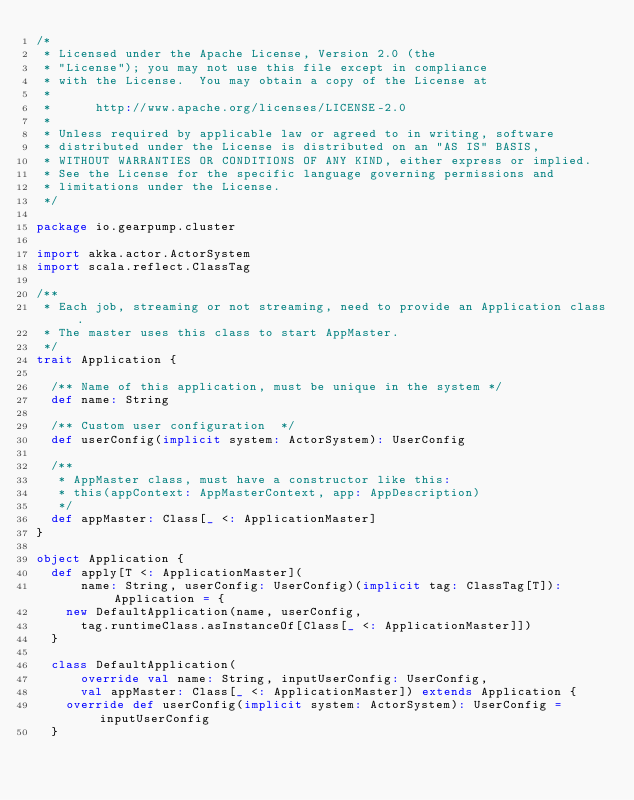Convert code to text. <code><loc_0><loc_0><loc_500><loc_500><_Scala_>/*
 * Licensed under the Apache License, Version 2.0 (the
 * "License"); you may not use this file except in compliance
 * with the License.  You may obtain a copy of the License at
 *
 *      http://www.apache.org/licenses/LICENSE-2.0
 *
 * Unless required by applicable law or agreed to in writing, software
 * distributed under the License is distributed on an "AS IS" BASIS,
 * WITHOUT WARRANTIES OR CONDITIONS OF ANY KIND, either express or implied.
 * See the License for the specific language governing permissions and
 * limitations under the License.
 */

package io.gearpump.cluster

import akka.actor.ActorSystem
import scala.reflect.ClassTag

/**
 * Each job, streaming or not streaming, need to provide an Application class.
 * The master uses this class to start AppMaster.
 */
trait Application {

  /** Name of this application, must be unique in the system */
  def name: String

  /** Custom user configuration  */
  def userConfig(implicit system: ActorSystem): UserConfig

  /**
   * AppMaster class, must have a constructor like this:
   * this(appContext: AppMasterContext, app: AppDescription)
   */
  def appMaster: Class[_ <: ApplicationMaster]
}

object Application {
  def apply[T <: ApplicationMaster](
      name: String, userConfig: UserConfig)(implicit tag: ClassTag[T]): Application = {
    new DefaultApplication(name, userConfig,
      tag.runtimeClass.asInstanceOf[Class[_ <: ApplicationMaster]])
  }

  class DefaultApplication(
      override val name: String, inputUserConfig: UserConfig,
      val appMaster: Class[_ <: ApplicationMaster]) extends Application {
    override def userConfig(implicit system: ActorSystem): UserConfig = inputUserConfig
  }
</code> 